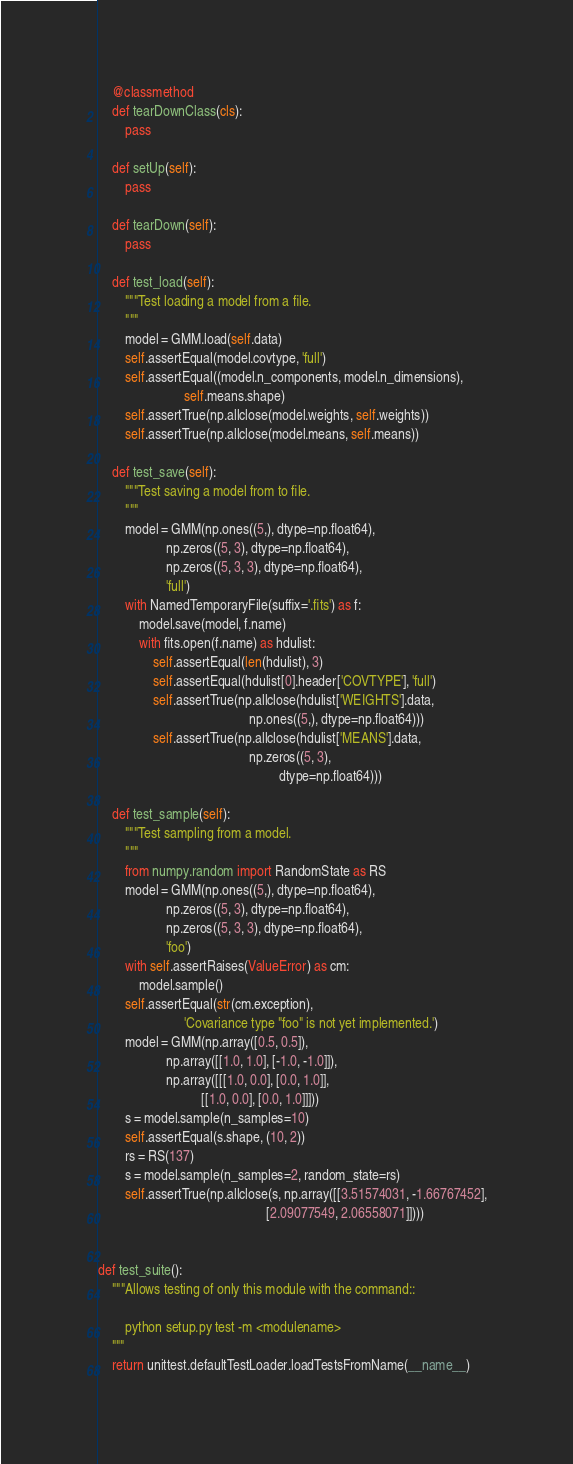Convert code to text. <code><loc_0><loc_0><loc_500><loc_500><_Python_>
    @classmethod
    def tearDownClass(cls):
        pass

    def setUp(self):
        pass

    def tearDown(self):
        pass

    def test_load(self):
        """Test loading a model from a file.
        """
        model = GMM.load(self.data)
        self.assertEqual(model.covtype, 'full')
        self.assertEqual((model.n_components, model.n_dimensions),
                         self.means.shape)
        self.assertTrue(np.allclose(model.weights, self.weights))
        self.assertTrue(np.allclose(model.means, self.means))

    def test_save(self):
        """Test saving a model from to file.
        """
        model = GMM(np.ones((5,), dtype=np.float64),
                    np.zeros((5, 3), dtype=np.float64),
                    np.zeros((5, 3, 3), dtype=np.float64),
                    'full')
        with NamedTemporaryFile(suffix='.fits') as f:
            model.save(model, f.name)
            with fits.open(f.name) as hdulist:
                self.assertEqual(len(hdulist), 3)
                self.assertEqual(hdulist[0].header['COVTYPE'], 'full')
                self.assertTrue(np.allclose(hdulist['WEIGHTS'].data,
                                            np.ones((5,), dtype=np.float64)))
                self.assertTrue(np.allclose(hdulist['MEANS'].data,
                                            np.zeros((5, 3),
                                                     dtype=np.float64)))

    def test_sample(self):
        """Test sampling from a model.
        """
        from numpy.random import RandomState as RS
        model = GMM(np.ones((5,), dtype=np.float64),
                    np.zeros((5, 3), dtype=np.float64),
                    np.zeros((5, 3, 3), dtype=np.float64),
                    'foo')
        with self.assertRaises(ValueError) as cm:
            model.sample()
        self.assertEqual(str(cm.exception),
                         'Covariance type "foo" is not yet implemented.')
        model = GMM(np.array([0.5, 0.5]),
                    np.array([[1.0, 1.0], [-1.0, -1.0]]),
                    np.array([[[1.0, 0.0], [0.0, 1.0]],
                              [[1.0, 0.0], [0.0, 1.0]]]))
        s = model.sample(n_samples=10)
        self.assertEqual(s.shape, (10, 2))
        rs = RS(137)
        s = model.sample(n_samples=2, random_state=rs)
        self.assertTrue(np.allclose(s, np.array([[3.51574031, -1.66767452],
                                                 [2.09077549, 2.06558071]])))


def test_suite():
    """Allows testing of only this module with the command::

        python setup.py test -m <modulename>
    """
    return unittest.defaultTestLoader.loadTestsFromName(__name__)
</code> 